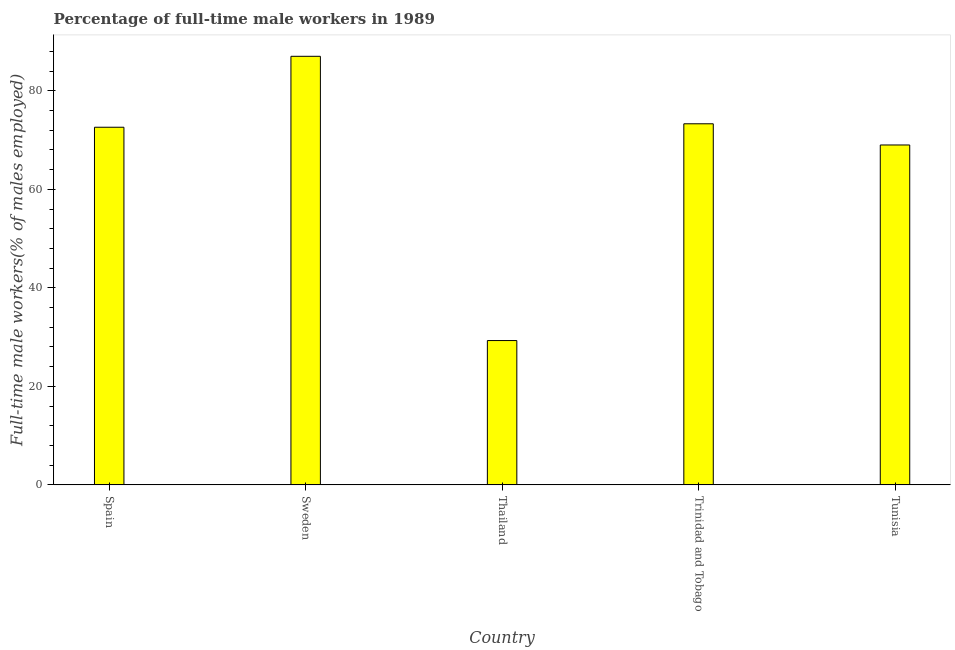Does the graph contain any zero values?
Your answer should be compact. No. What is the title of the graph?
Ensure brevity in your answer.  Percentage of full-time male workers in 1989. What is the label or title of the X-axis?
Offer a terse response. Country. What is the label or title of the Y-axis?
Offer a very short reply. Full-time male workers(% of males employed). What is the percentage of full-time male workers in Tunisia?
Offer a very short reply. 69. Across all countries, what is the minimum percentage of full-time male workers?
Provide a short and direct response. 29.3. In which country was the percentage of full-time male workers minimum?
Offer a terse response. Thailand. What is the sum of the percentage of full-time male workers?
Make the answer very short. 331.2. What is the difference between the percentage of full-time male workers in Trinidad and Tobago and Tunisia?
Your answer should be very brief. 4.3. What is the average percentage of full-time male workers per country?
Keep it short and to the point. 66.24. What is the median percentage of full-time male workers?
Your answer should be compact. 72.6. In how many countries, is the percentage of full-time male workers greater than 12 %?
Your answer should be compact. 5. What is the ratio of the percentage of full-time male workers in Spain to that in Sweden?
Your response must be concise. 0.83. Is the percentage of full-time male workers in Sweden less than that in Thailand?
Keep it short and to the point. No. Is the difference between the percentage of full-time male workers in Spain and Thailand greater than the difference between any two countries?
Give a very brief answer. No. What is the difference between the highest and the second highest percentage of full-time male workers?
Provide a succinct answer. 13.7. Is the sum of the percentage of full-time male workers in Spain and Sweden greater than the maximum percentage of full-time male workers across all countries?
Make the answer very short. Yes. What is the difference between the highest and the lowest percentage of full-time male workers?
Your response must be concise. 57.7. In how many countries, is the percentage of full-time male workers greater than the average percentage of full-time male workers taken over all countries?
Offer a very short reply. 4. Are all the bars in the graph horizontal?
Provide a short and direct response. No. How many countries are there in the graph?
Provide a succinct answer. 5. What is the difference between two consecutive major ticks on the Y-axis?
Provide a succinct answer. 20. What is the Full-time male workers(% of males employed) of Spain?
Your response must be concise. 72.6. What is the Full-time male workers(% of males employed) in Sweden?
Offer a very short reply. 87. What is the Full-time male workers(% of males employed) in Thailand?
Give a very brief answer. 29.3. What is the Full-time male workers(% of males employed) of Trinidad and Tobago?
Offer a very short reply. 73.3. What is the Full-time male workers(% of males employed) in Tunisia?
Your answer should be very brief. 69. What is the difference between the Full-time male workers(% of males employed) in Spain and Sweden?
Offer a very short reply. -14.4. What is the difference between the Full-time male workers(% of males employed) in Spain and Thailand?
Your response must be concise. 43.3. What is the difference between the Full-time male workers(% of males employed) in Spain and Trinidad and Tobago?
Offer a terse response. -0.7. What is the difference between the Full-time male workers(% of males employed) in Spain and Tunisia?
Provide a short and direct response. 3.6. What is the difference between the Full-time male workers(% of males employed) in Sweden and Thailand?
Provide a succinct answer. 57.7. What is the difference between the Full-time male workers(% of males employed) in Thailand and Trinidad and Tobago?
Ensure brevity in your answer.  -44. What is the difference between the Full-time male workers(% of males employed) in Thailand and Tunisia?
Your response must be concise. -39.7. What is the ratio of the Full-time male workers(% of males employed) in Spain to that in Sweden?
Your answer should be very brief. 0.83. What is the ratio of the Full-time male workers(% of males employed) in Spain to that in Thailand?
Your response must be concise. 2.48. What is the ratio of the Full-time male workers(% of males employed) in Spain to that in Tunisia?
Offer a terse response. 1.05. What is the ratio of the Full-time male workers(% of males employed) in Sweden to that in Thailand?
Your response must be concise. 2.97. What is the ratio of the Full-time male workers(% of males employed) in Sweden to that in Trinidad and Tobago?
Provide a short and direct response. 1.19. What is the ratio of the Full-time male workers(% of males employed) in Sweden to that in Tunisia?
Your answer should be compact. 1.26. What is the ratio of the Full-time male workers(% of males employed) in Thailand to that in Trinidad and Tobago?
Your response must be concise. 0.4. What is the ratio of the Full-time male workers(% of males employed) in Thailand to that in Tunisia?
Your answer should be very brief. 0.42. What is the ratio of the Full-time male workers(% of males employed) in Trinidad and Tobago to that in Tunisia?
Your answer should be compact. 1.06. 